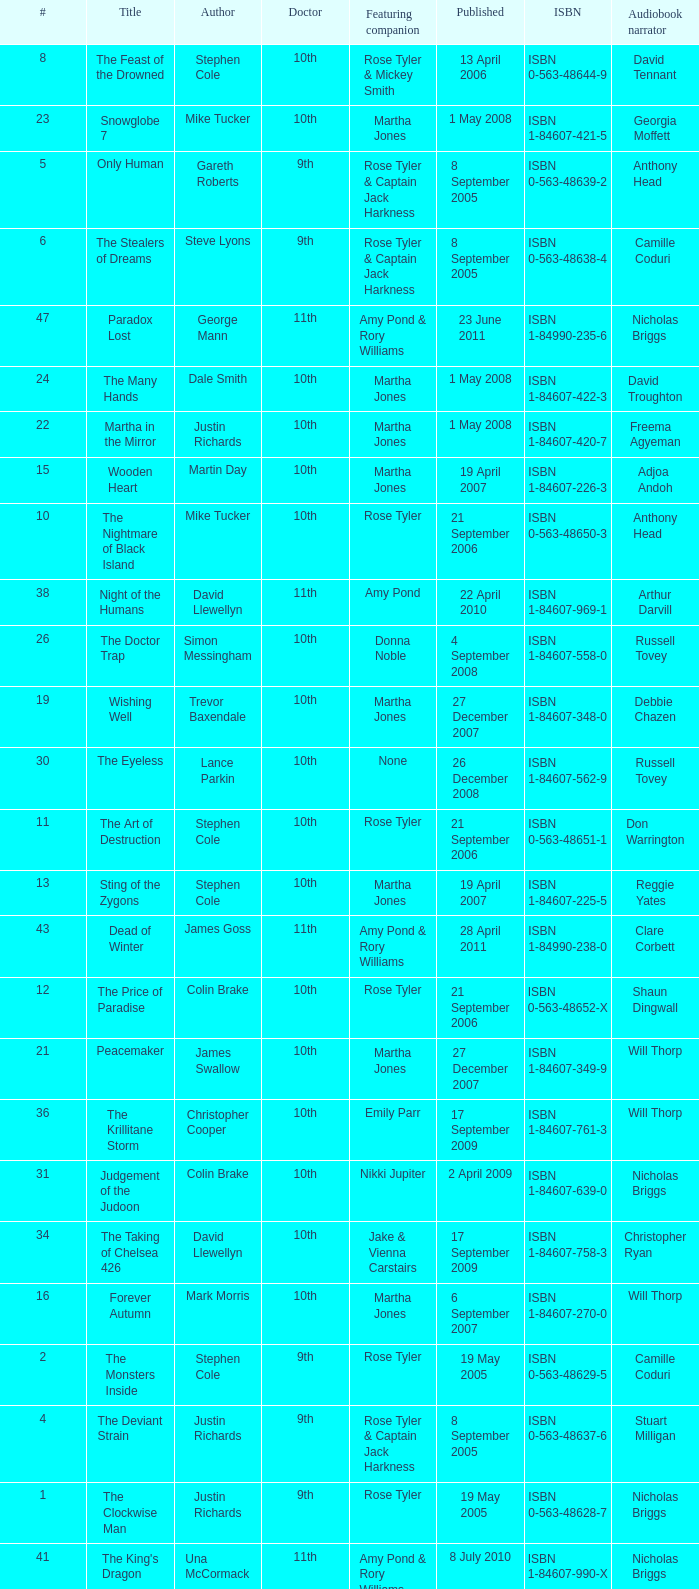What is the title of book number 8? The Feast of the Drowned. 